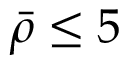<formula> <loc_0><loc_0><loc_500><loc_500>\bar { \rho } \leq 5</formula> 